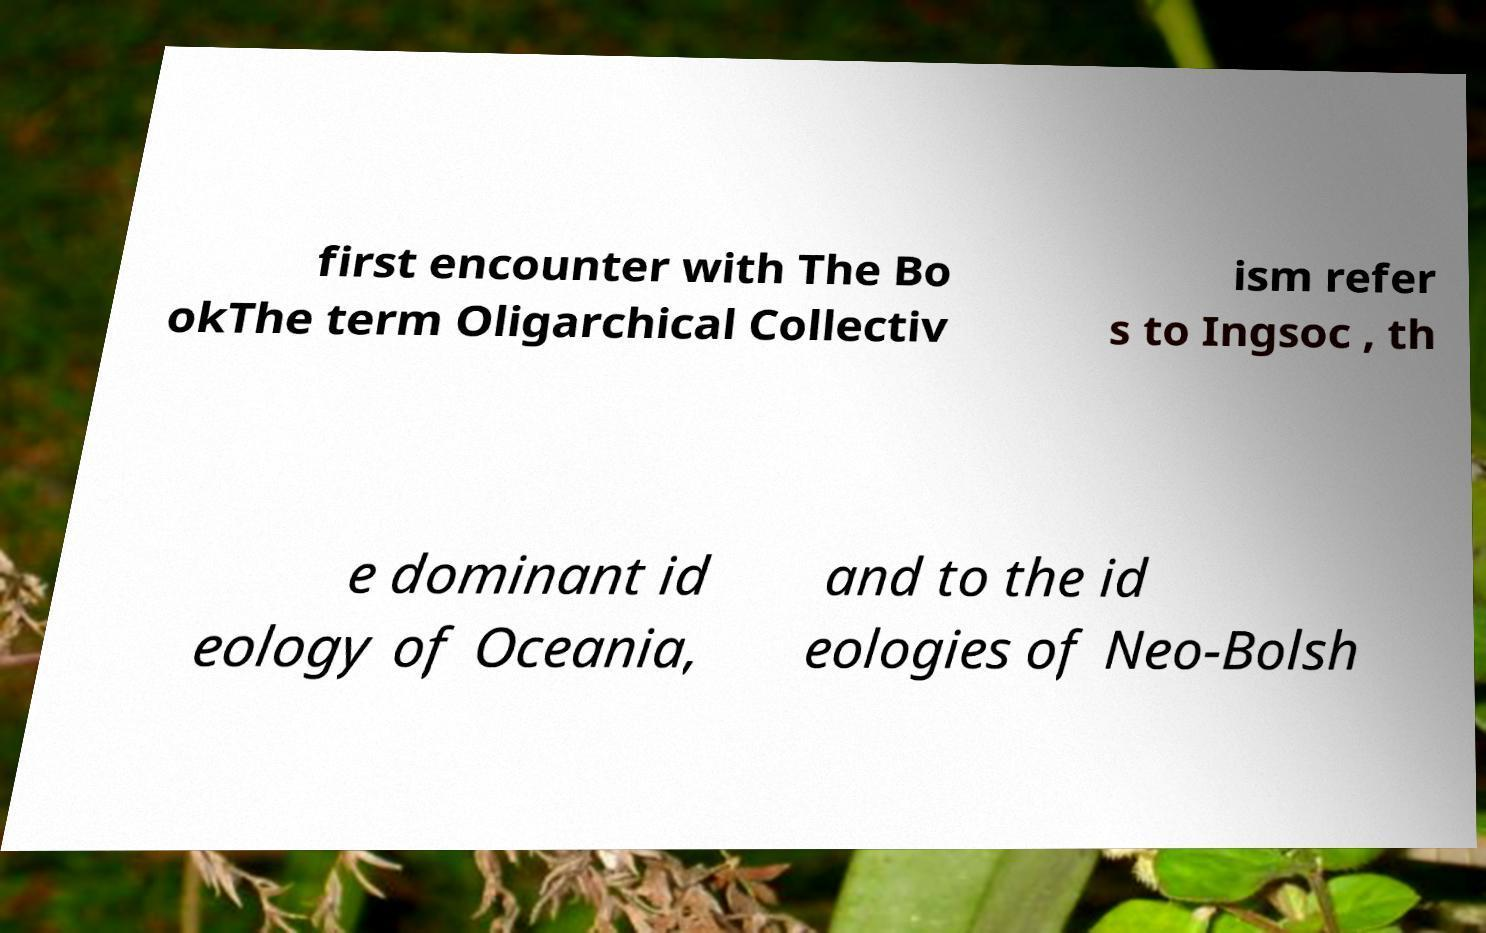I need the written content from this picture converted into text. Can you do that? first encounter with The Bo okThe term Oligarchical Collectiv ism refer s to Ingsoc , th e dominant id eology of Oceania, and to the id eologies of Neo-Bolsh 